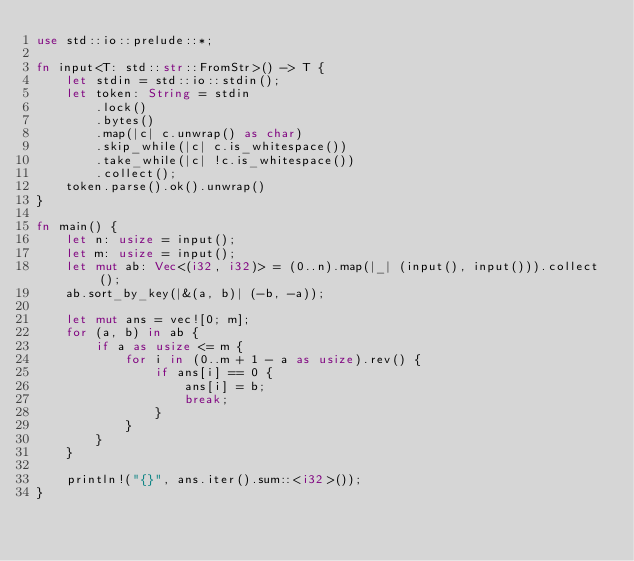<code> <loc_0><loc_0><loc_500><loc_500><_Rust_>use std::io::prelude::*;

fn input<T: std::str::FromStr>() -> T {
    let stdin = std::io::stdin();
    let token: String = stdin
        .lock()
        .bytes()
        .map(|c| c.unwrap() as char)
        .skip_while(|c| c.is_whitespace())
        .take_while(|c| !c.is_whitespace())
        .collect();
    token.parse().ok().unwrap()
}

fn main() {
    let n: usize = input();
    let m: usize = input();
    let mut ab: Vec<(i32, i32)> = (0..n).map(|_| (input(), input())).collect();
    ab.sort_by_key(|&(a, b)| (-b, -a));

    let mut ans = vec![0; m];
    for (a, b) in ab {
        if a as usize <= m {
            for i in (0..m + 1 - a as usize).rev() {
                if ans[i] == 0 {
                    ans[i] = b;
                    break;
                }
            }
        }
    }

    println!("{}", ans.iter().sum::<i32>());
}
</code> 